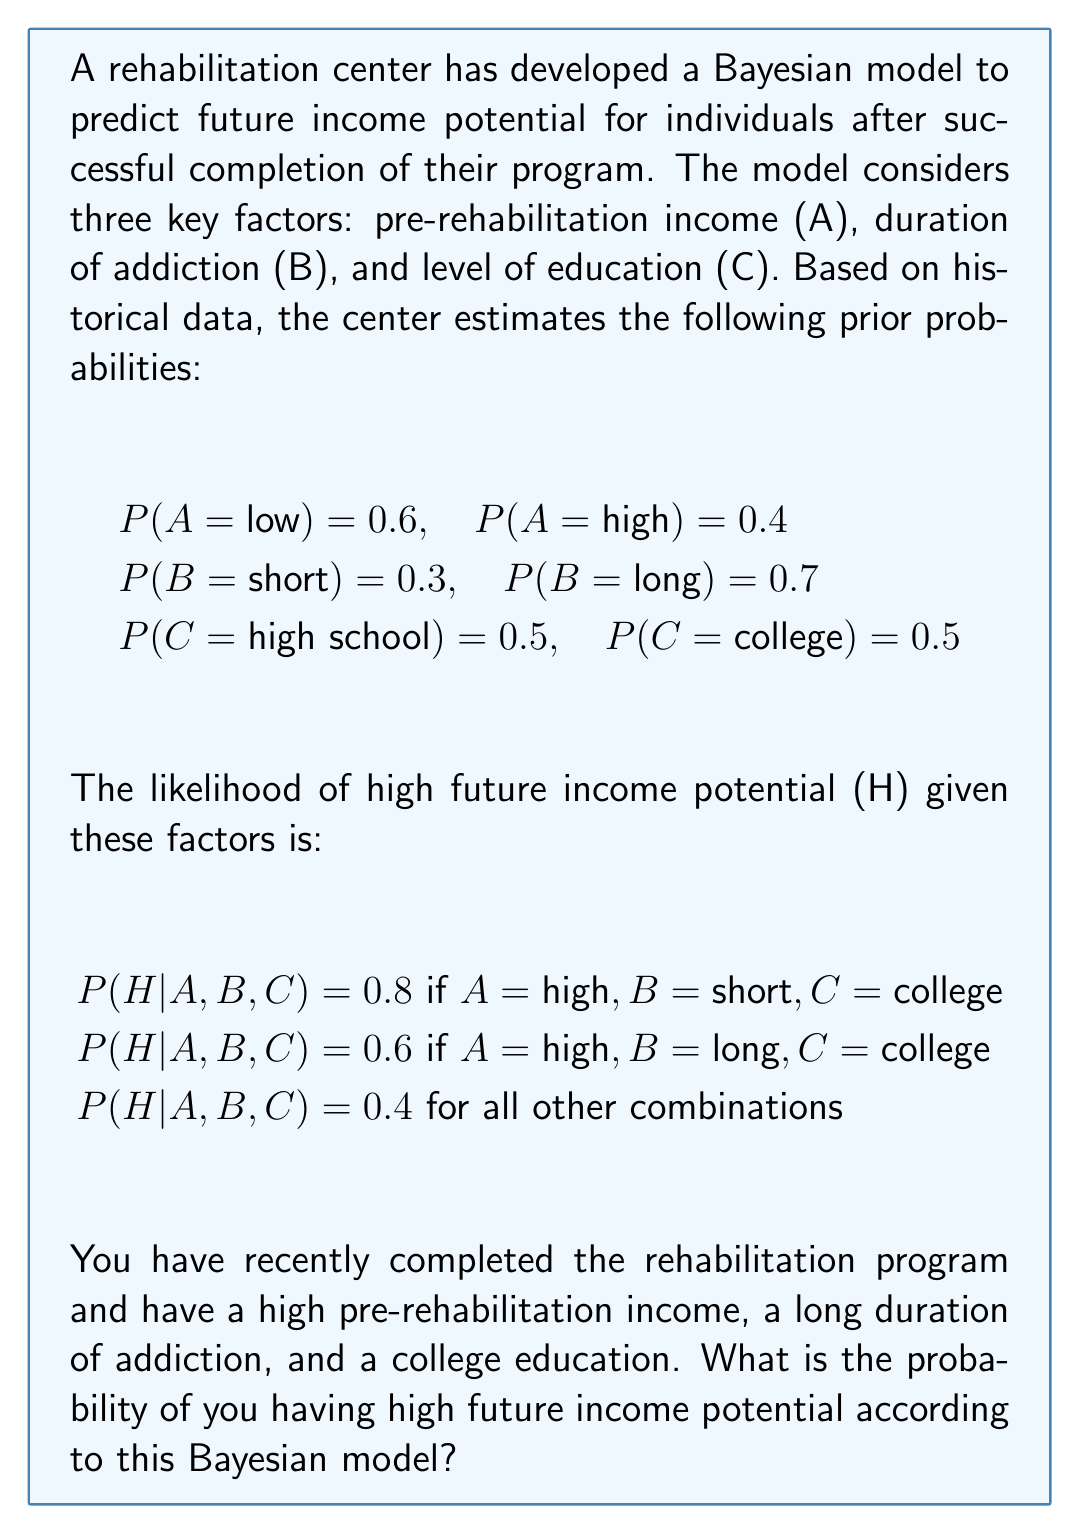Can you solve this math problem? To solve this problem, we'll use Bayes' theorem and the given information. Let's break it down step by step:

1. Identify the relevant probabilities:
   P(A = high) = 0.4
   P(B = long) = 0.7
   P(C = college) = 0.5
   P(H|A = high, B = long, C = college) = 0.6

2. We need to calculate P(H|A,B,C) for our specific case. We can use Bayes' theorem:

   $$P(H|A,B,C) = \frac{P(H|A,B,C) \cdot P(A) \cdot P(B) \cdot P(C)}{P(H)}$$

3. We know the numerator:
   $$P(H|A,B,C) \cdot P(A) \cdot P(B) \cdot P(C) = 0.6 \cdot 0.4 \cdot 0.7 \cdot 0.5 = 0.084$$

4. To find P(H), we need to sum over all possible combinations:
   $$P(H) = \sum_{A,B,C} P(H|A,B,C) \cdot P(A) \cdot P(B) \cdot P(C)$$

5. Let's calculate this sum:
   
   High income, short duration, college: 
   $$0.8 \cdot 0.4 \cdot 0.3 \cdot 0.5 = 0.048$$
   
   High income, long duration, college: 
   $$0.6 \cdot 0.4 \cdot 0.7 \cdot 0.5 = 0.084$$
   
   All other combinations (6 in total): 
   $$6 \cdot 0.4 \cdot 0.5 \cdot 0.5 \cdot 0.5 = 0.3$$

   $$P(H) = 0.048 + 0.084 + 0.3 = 0.432$$

6. Now we can calculate the final probability:

   $$P(H|A,B,C) = \frac{0.084}{0.432} \approx 0.1944$$
Answer: The probability of having high future income potential according to this Bayesian model is approximately 0.1944 or 19.44%. 